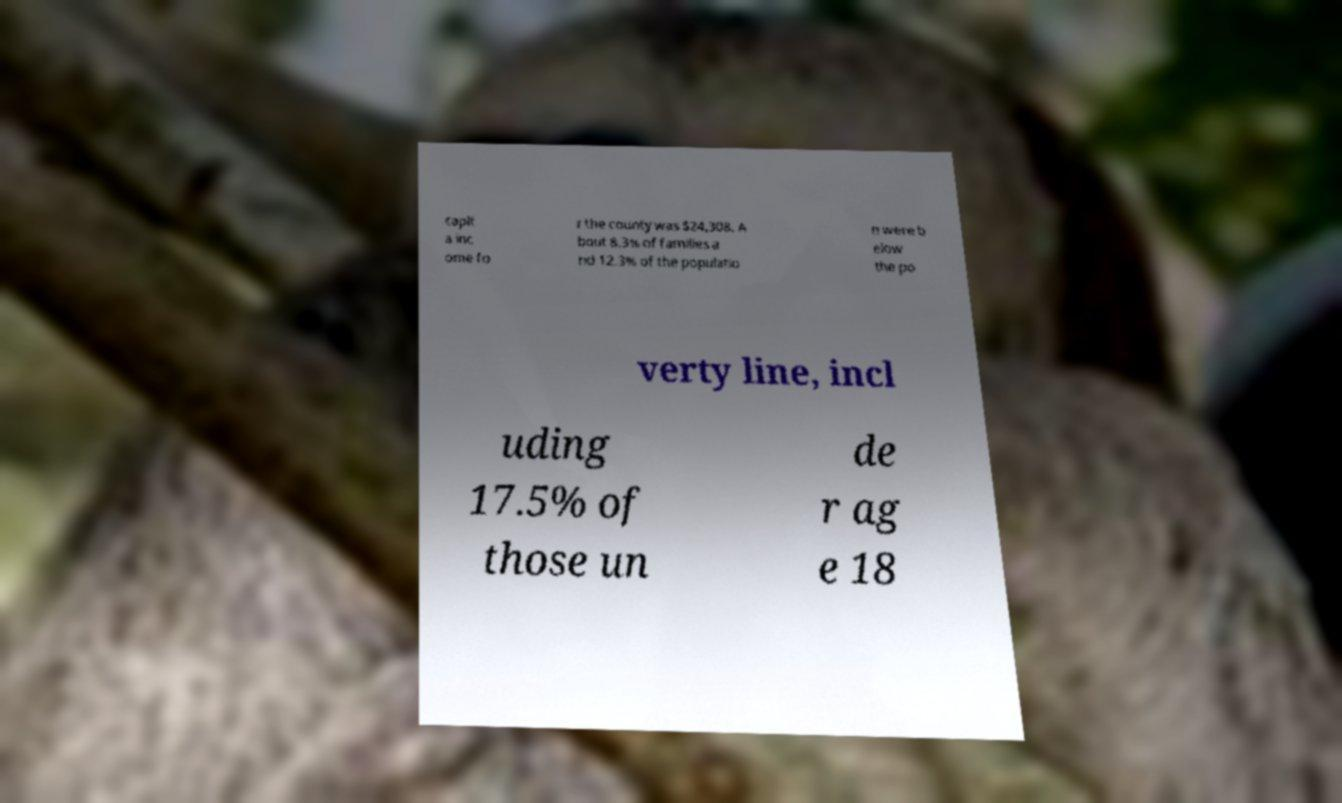I need the written content from this picture converted into text. Can you do that? capit a inc ome fo r the county was $24,308. A bout 8.3% of families a nd 12.3% of the populatio n were b elow the po verty line, incl uding 17.5% of those un de r ag e 18 